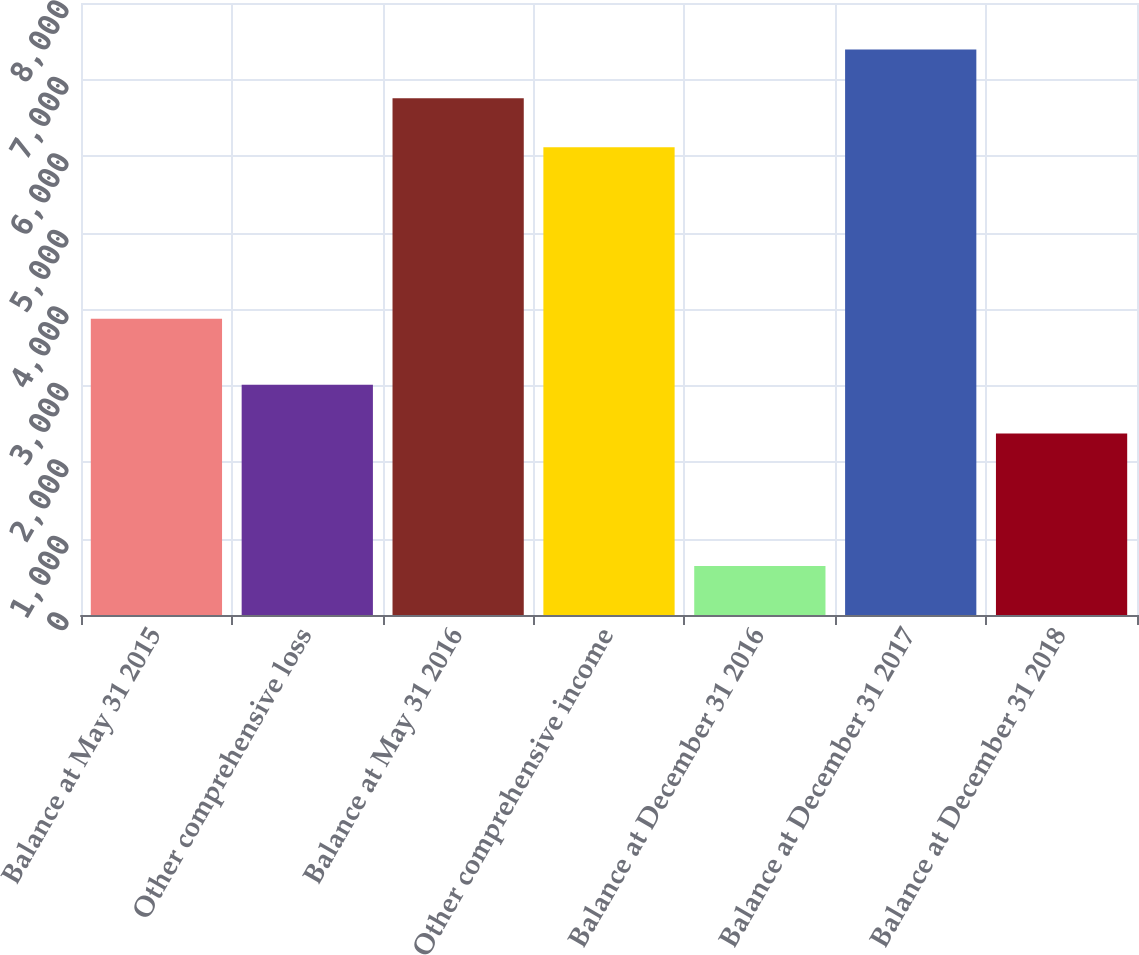Convert chart. <chart><loc_0><loc_0><loc_500><loc_500><bar_chart><fcel>Balance at May 31 2015<fcel>Other comprehensive loss<fcel>Balance at May 31 2016<fcel>Other comprehensive income<fcel>Balance at December 31 2016<fcel>Balance at December 31 2017<fcel>Balance at December 31 2018<nl><fcel>3874<fcel>3009.9<fcel>6755<fcel>6115<fcel>640<fcel>7390.9<fcel>2374<nl></chart> 